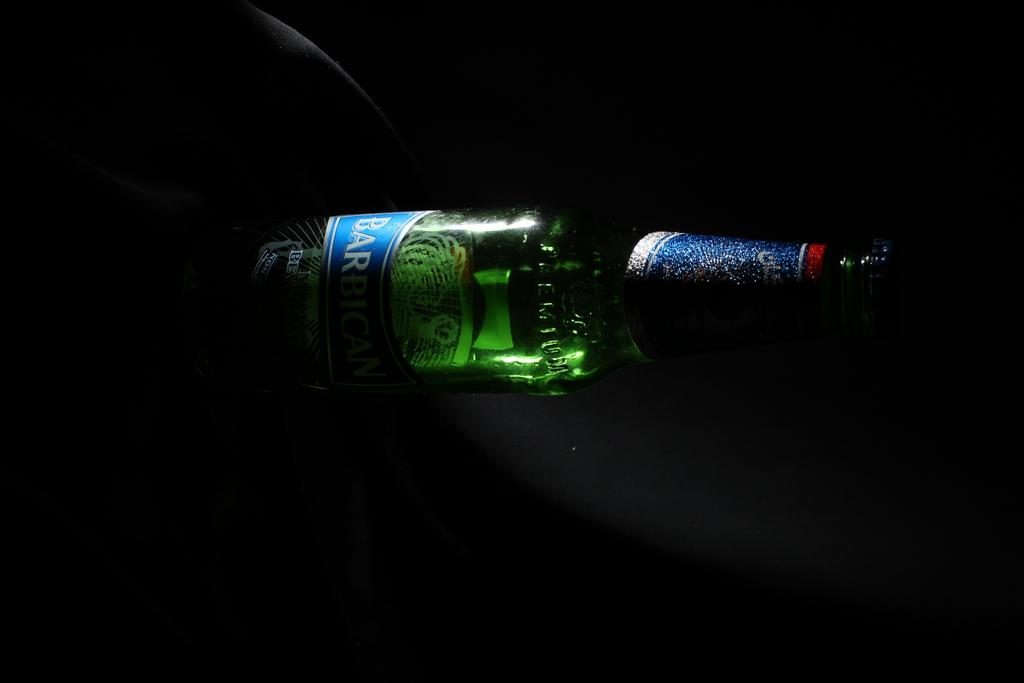What is the main object in the image? There is a wine bottle in the image. What type of steel is used to manufacture the wine bottle in the image? There is no information provided about the material used to manufacture the wine bottle, and therefore we cannot determine the type of steel used. 